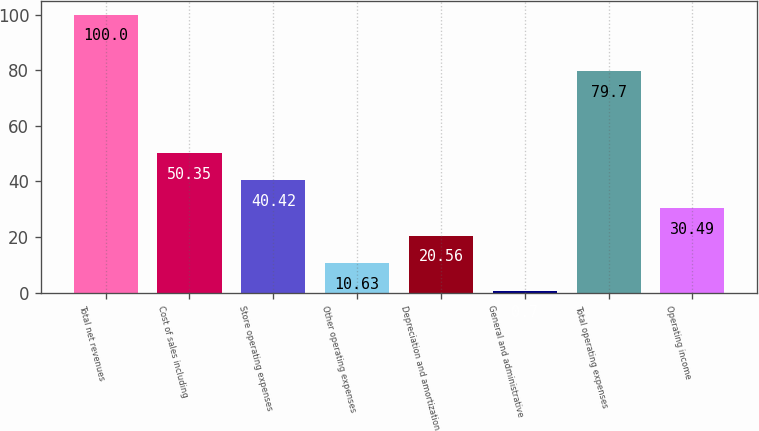Convert chart to OTSL. <chart><loc_0><loc_0><loc_500><loc_500><bar_chart><fcel>Total net revenues<fcel>Cost of sales including<fcel>Store operating expenses<fcel>Other operating expenses<fcel>Depreciation and amortization<fcel>General and administrative<fcel>Total operating expenses<fcel>Operating income<nl><fcel>100<fcel>50.35<fcel>40.42<fcel>10.63<fcel>20.56<fcel>0.7<fcel>79.7<fcel>30.49<nl></chart> 